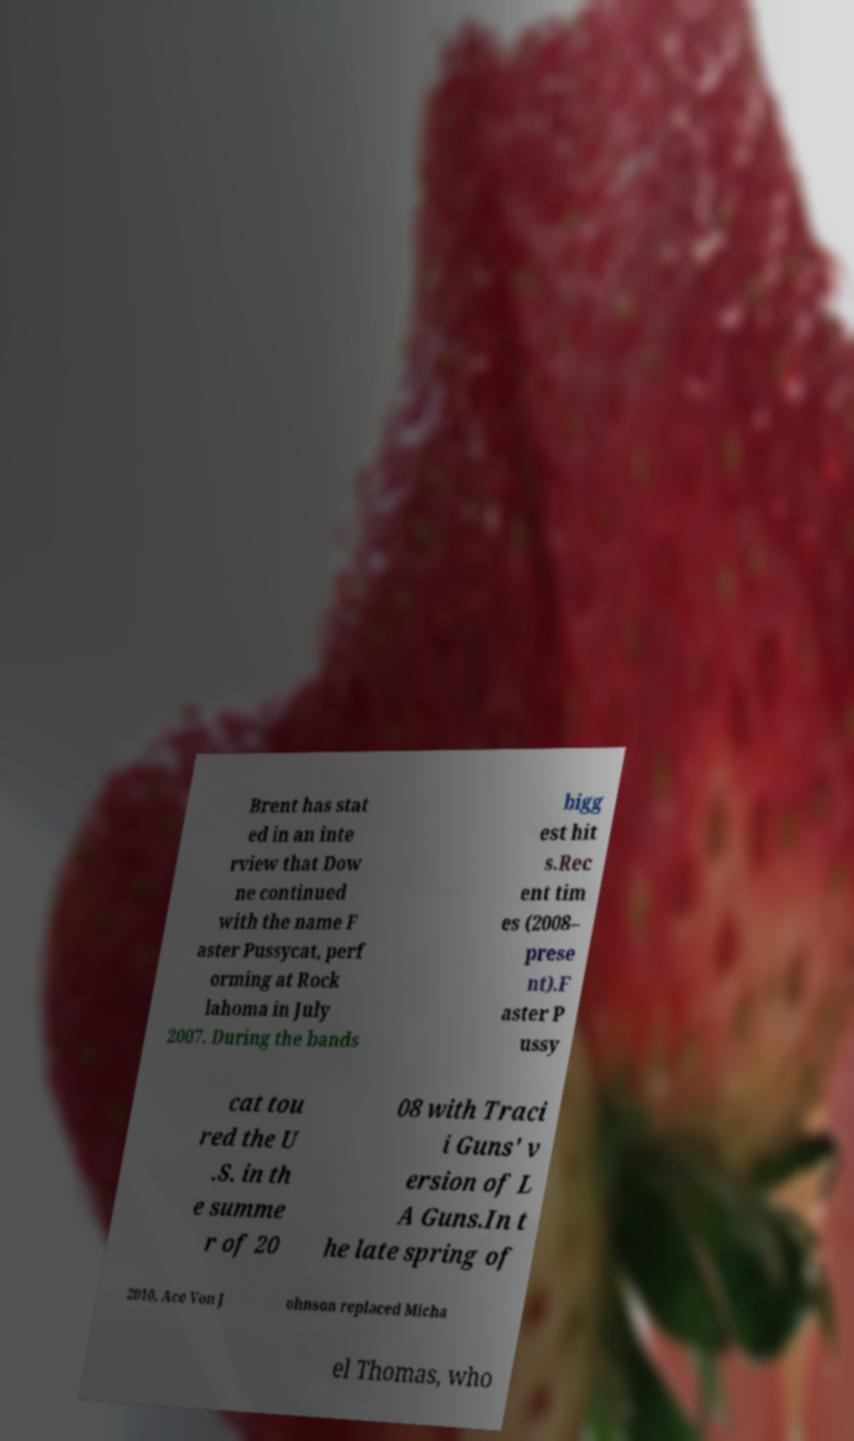For documentation purposes, I need the text within this image transcribed. Could you provide that? Brent has stat ed in an inte rview that Dow ne continued with the name F aster Pussycat, perf orming at Rock lahoma in July 2007. During the bands bigg est hit s.Rec ent tim es (2008– prese nt).F aster P ussy cat tou red the U .S. in th e summe r of 20 08 with Traci i Guns' v ersion of L A Guns.In t he late spring of 2010, Ace Von J ohnson replaced Micha el Thomas, who 